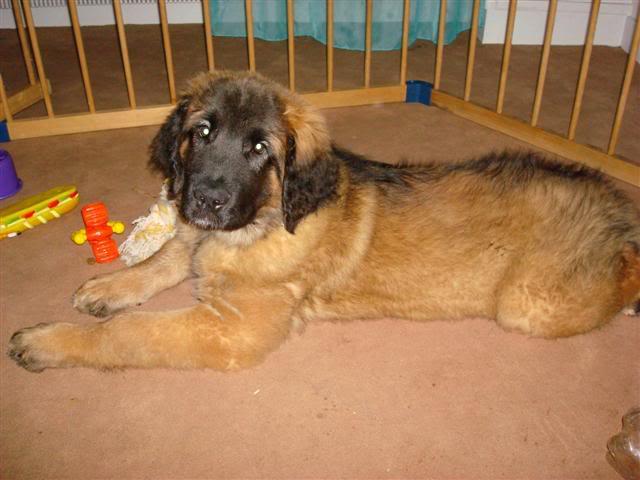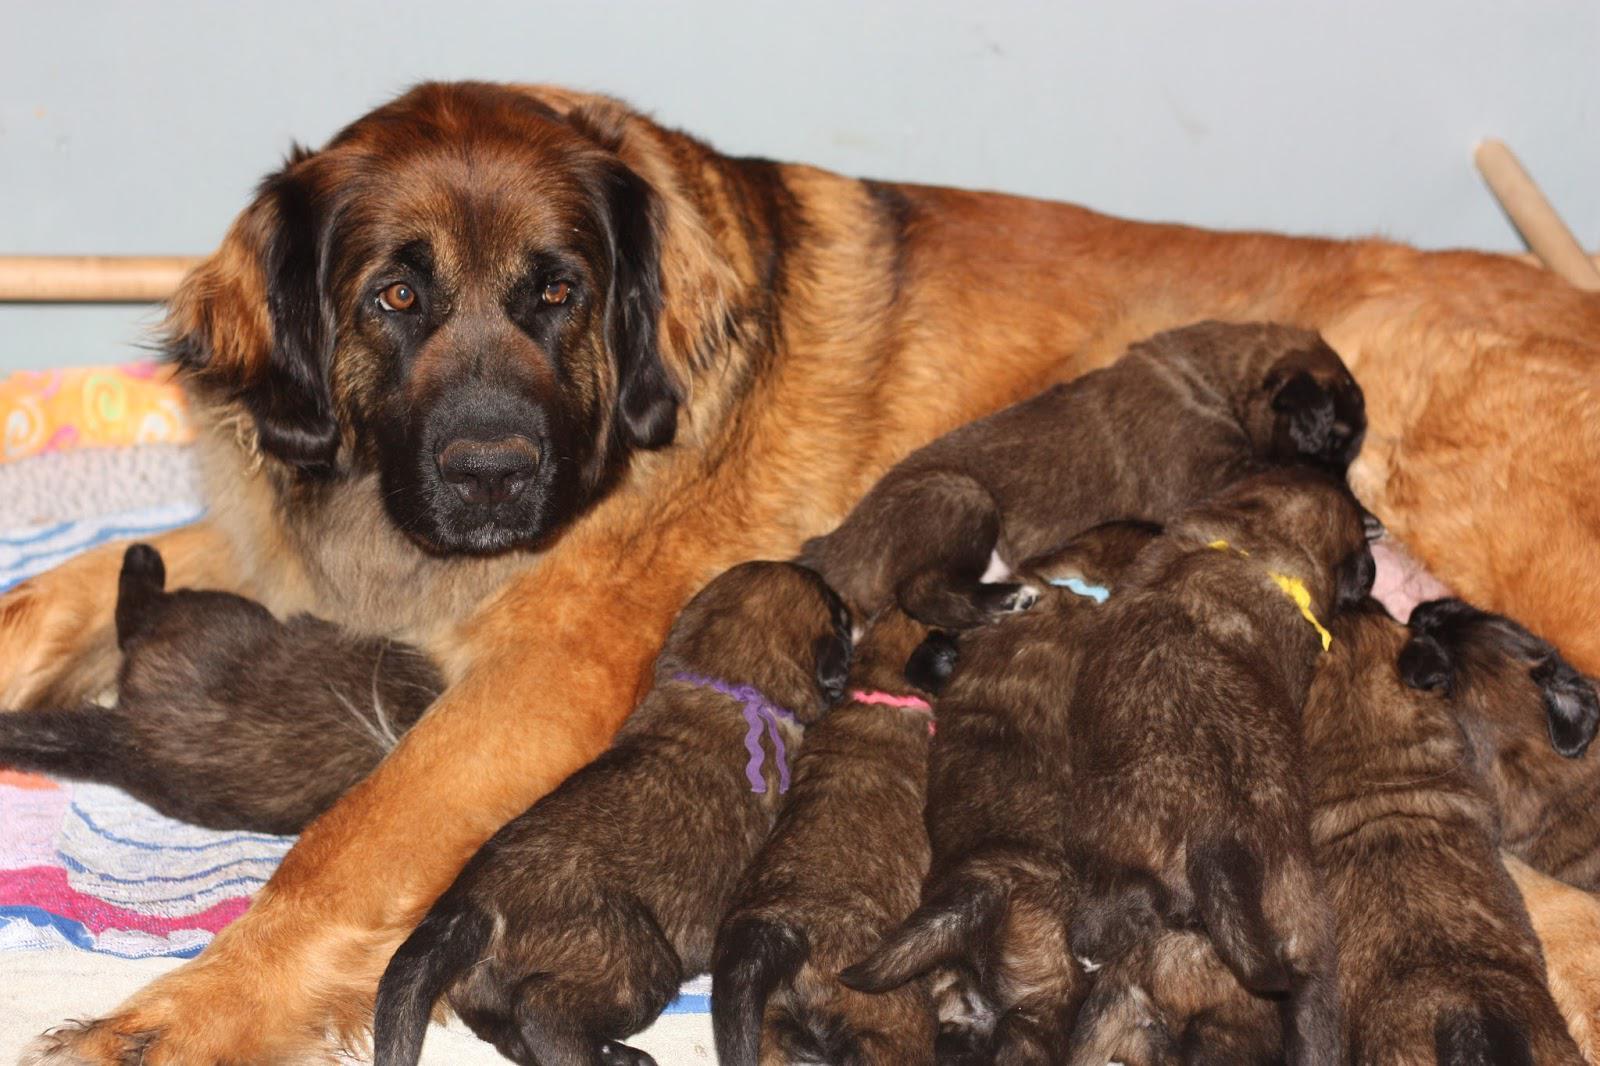The first image is the image on the left, the second image is the image on the right. Given the left and right images, does the statement "The dog on the right is nursing a pile of brown puppies, while the dog on the left is all alone, and an image shows a wood frame forming a corner around a dog." hold true? Answer yes or no. Yes. The first image is the image on the left, the second image is the image on the right. Considering the images on both sides, is "An adult dog is lying on her side with front legs extended outward while her puppies crowd in to nurse, while a second image shows a large dog lying on a floor." valid? Answer yes or no. Yes. 